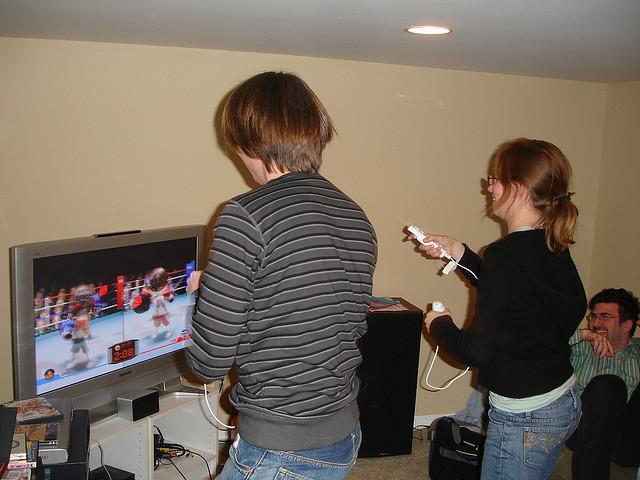Do you see a clock on the wall?
Concise answer only. No. What are the people holding in their hands?
Keep it brief. Wii controllers. Are they having fun?
Answer briefly. Yes. How many people in this photo?
Quick response, please. 3. Is the game in the photo a "Wii" game?
Short answer required. Yes. 